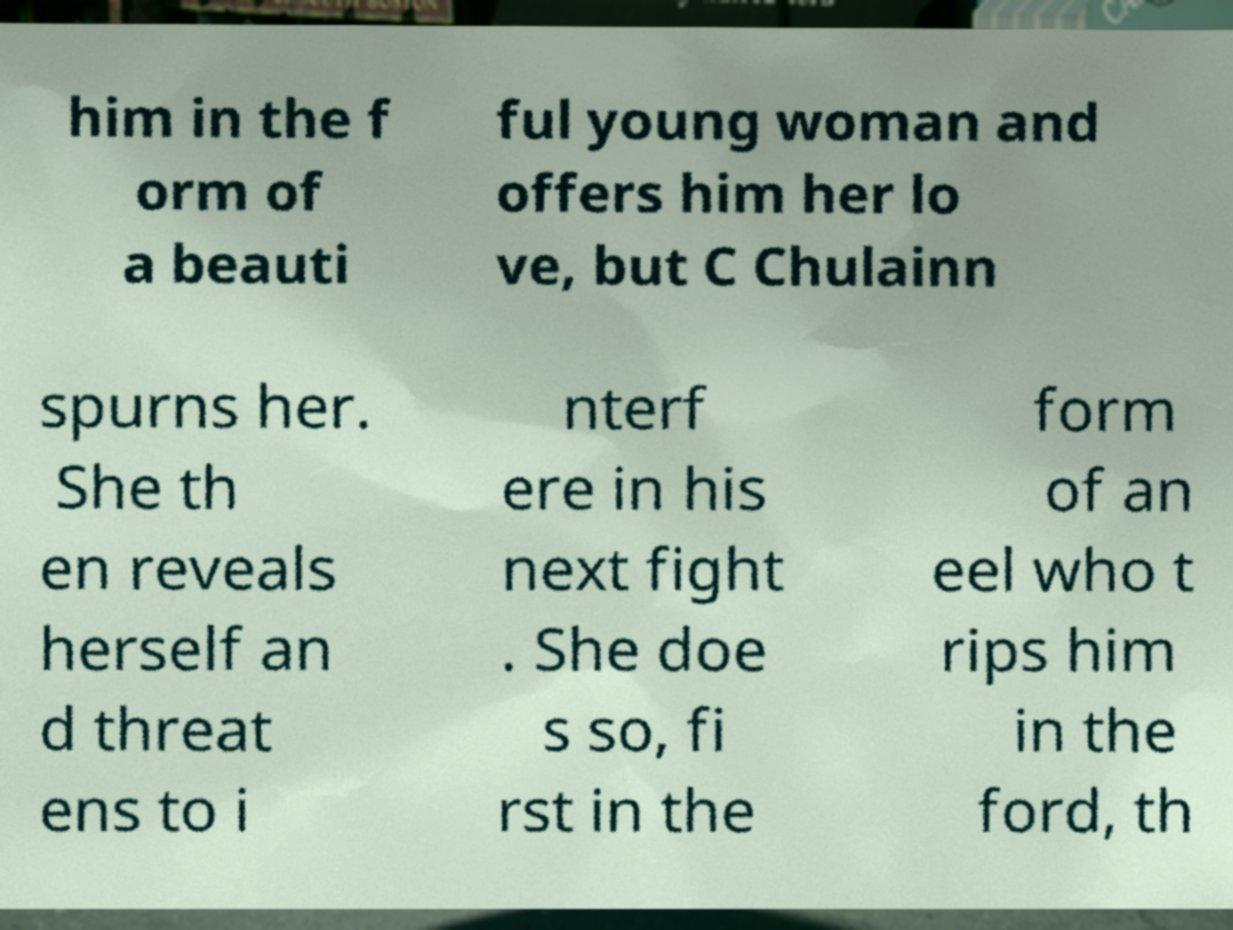Could you assist in decoding the text presented in this image and type it out clearly? him in the f orm of a beauti ful young woman and offers him her lo ve, but C Chulainn spurns her. She th en reveals herself an d threat ens to i nterf ere in his next fight . She doe s so, fi rst in the form of an eel who t rips him in the ford, th 